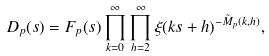<formula> <loc_0><loc_0><loc_500><loc_500>D _ { p } ( s ) = F _ { p } ( s ) \prod _ { k = 0 } ^ { \infty } \prod _ { h = 2 } ^ { \infty } \xi ( k s + h ) ^ { - \tilde { M } _ { p } ( k , h ) } ,</formula> 